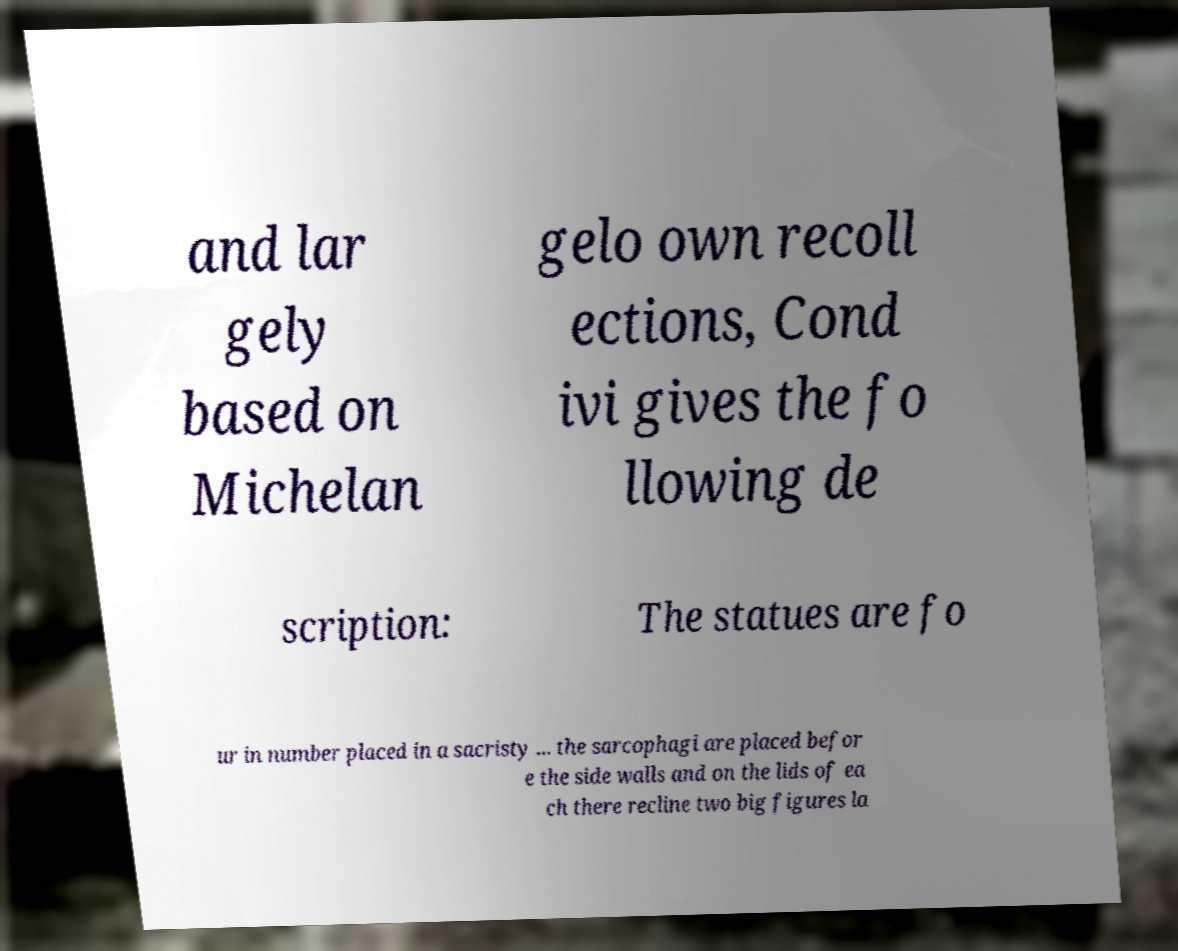Can you read and provide the text displayed in the image?This photo seems to have some interesting text. Can you extract and type it out for me? and lar gely based on Michelan gelo own recoll ections, Cond ivi gives the fo llowing de scription: The statues are fo ur in number placed in a sacristy ... the sarcophagi are placed befor e the side walls and on the lids of ea ch there recline two big figures la 